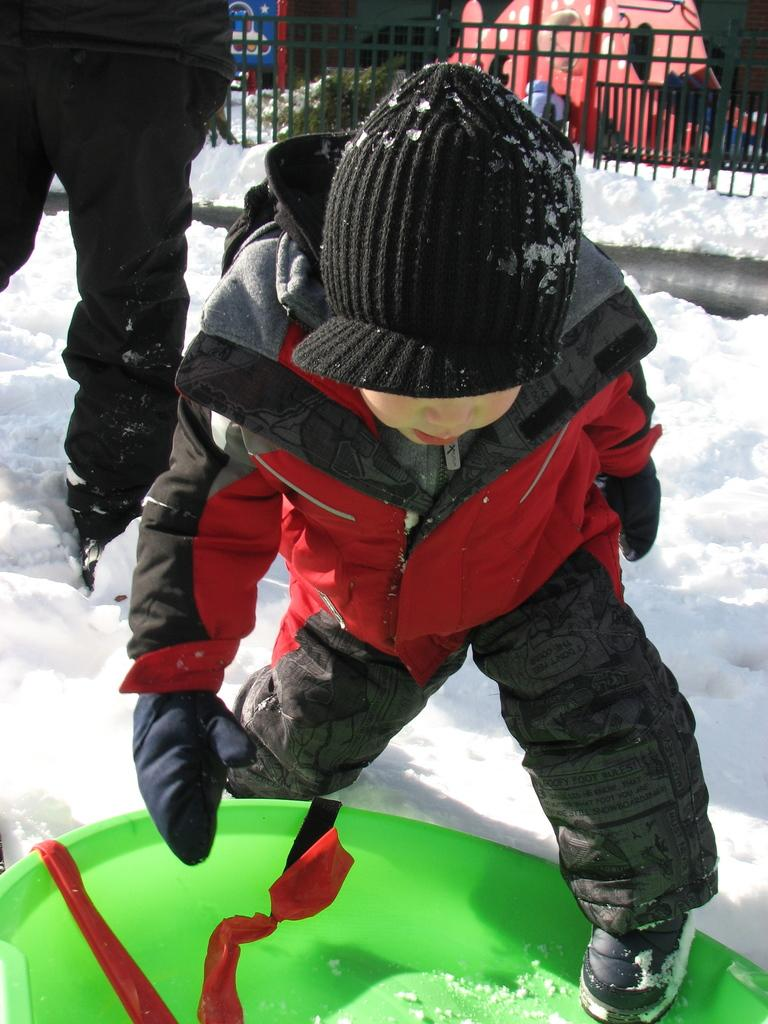What is the main subject in the foreground of the image? There is a child in the foreground of the image. Can you describe the person in the background of the image? There is a person standing in the background of the image. What type of weather is depicted in the image? The image contains snow, indicating a cold or wintry setting. What type of quince is being held by the fireman in the image? There is no fireman or quince present in the image. How does the stomach of the child in the image feel after playing in the snow? We cannot determine how the child's stomach feels from the image alone, as it does not provide information about their physical sensations. 